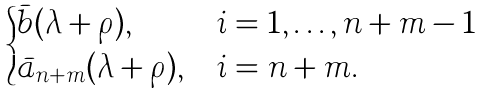Convert formula to latex. <formula><loc_0><loc_0><loc_500><loc_500>\begin{cases} \bar { b } ( \lambda + \rho ) , & i = 1 , \dots , n + m - 1 \\ \bar { a } _ { n + m } ( \lambda + \rho ) , & i = n + m . \end{cases}</formula> 